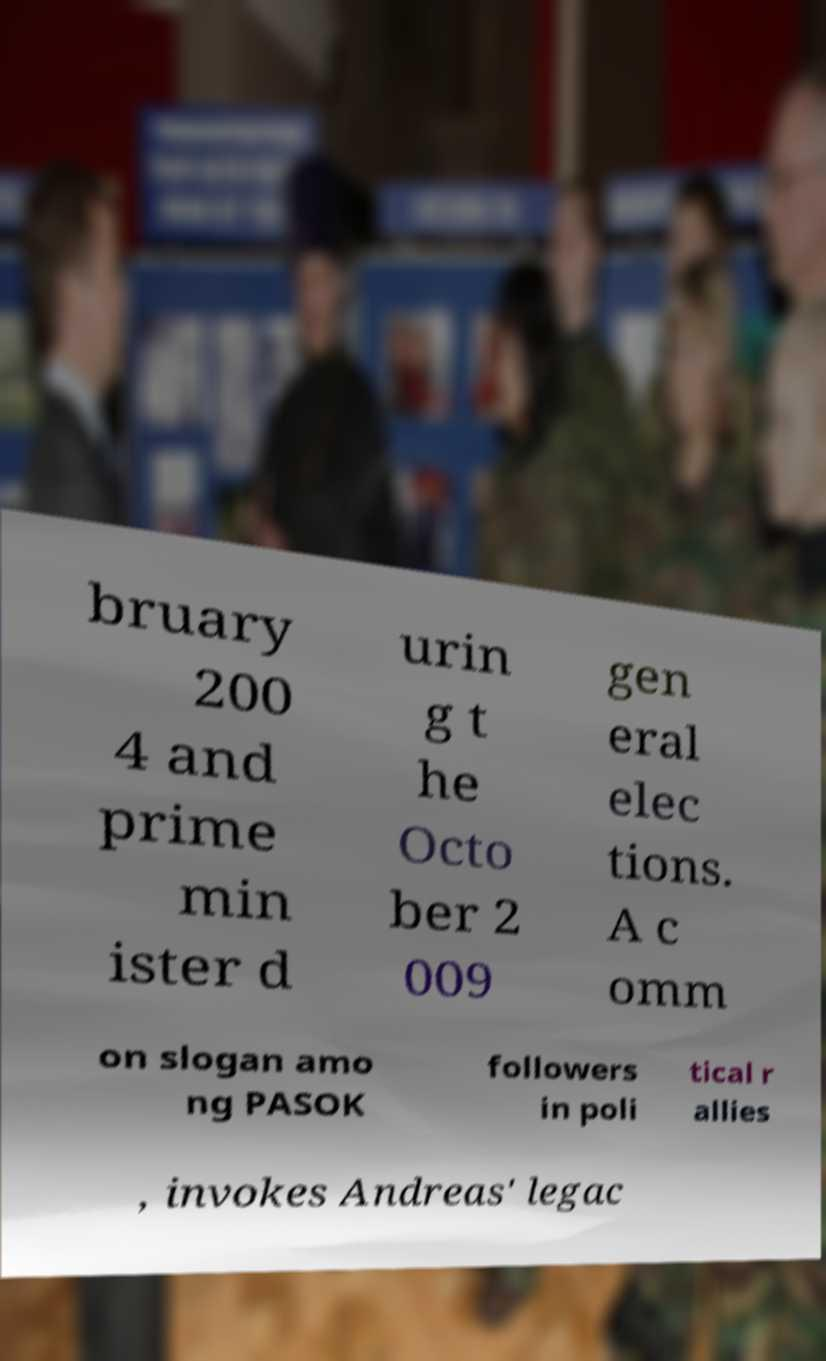Can you read and provide the text displayed in the image?This photo seems to have some interesting text. Can you extract and type it out for me? bruary 200 4 and prime min ister d urin g t he Octo ber 2 009 gen eral elec tions. A c omm on slogan amo ng PASOK followers in poli tical r allies , invokes Andreas' legac 